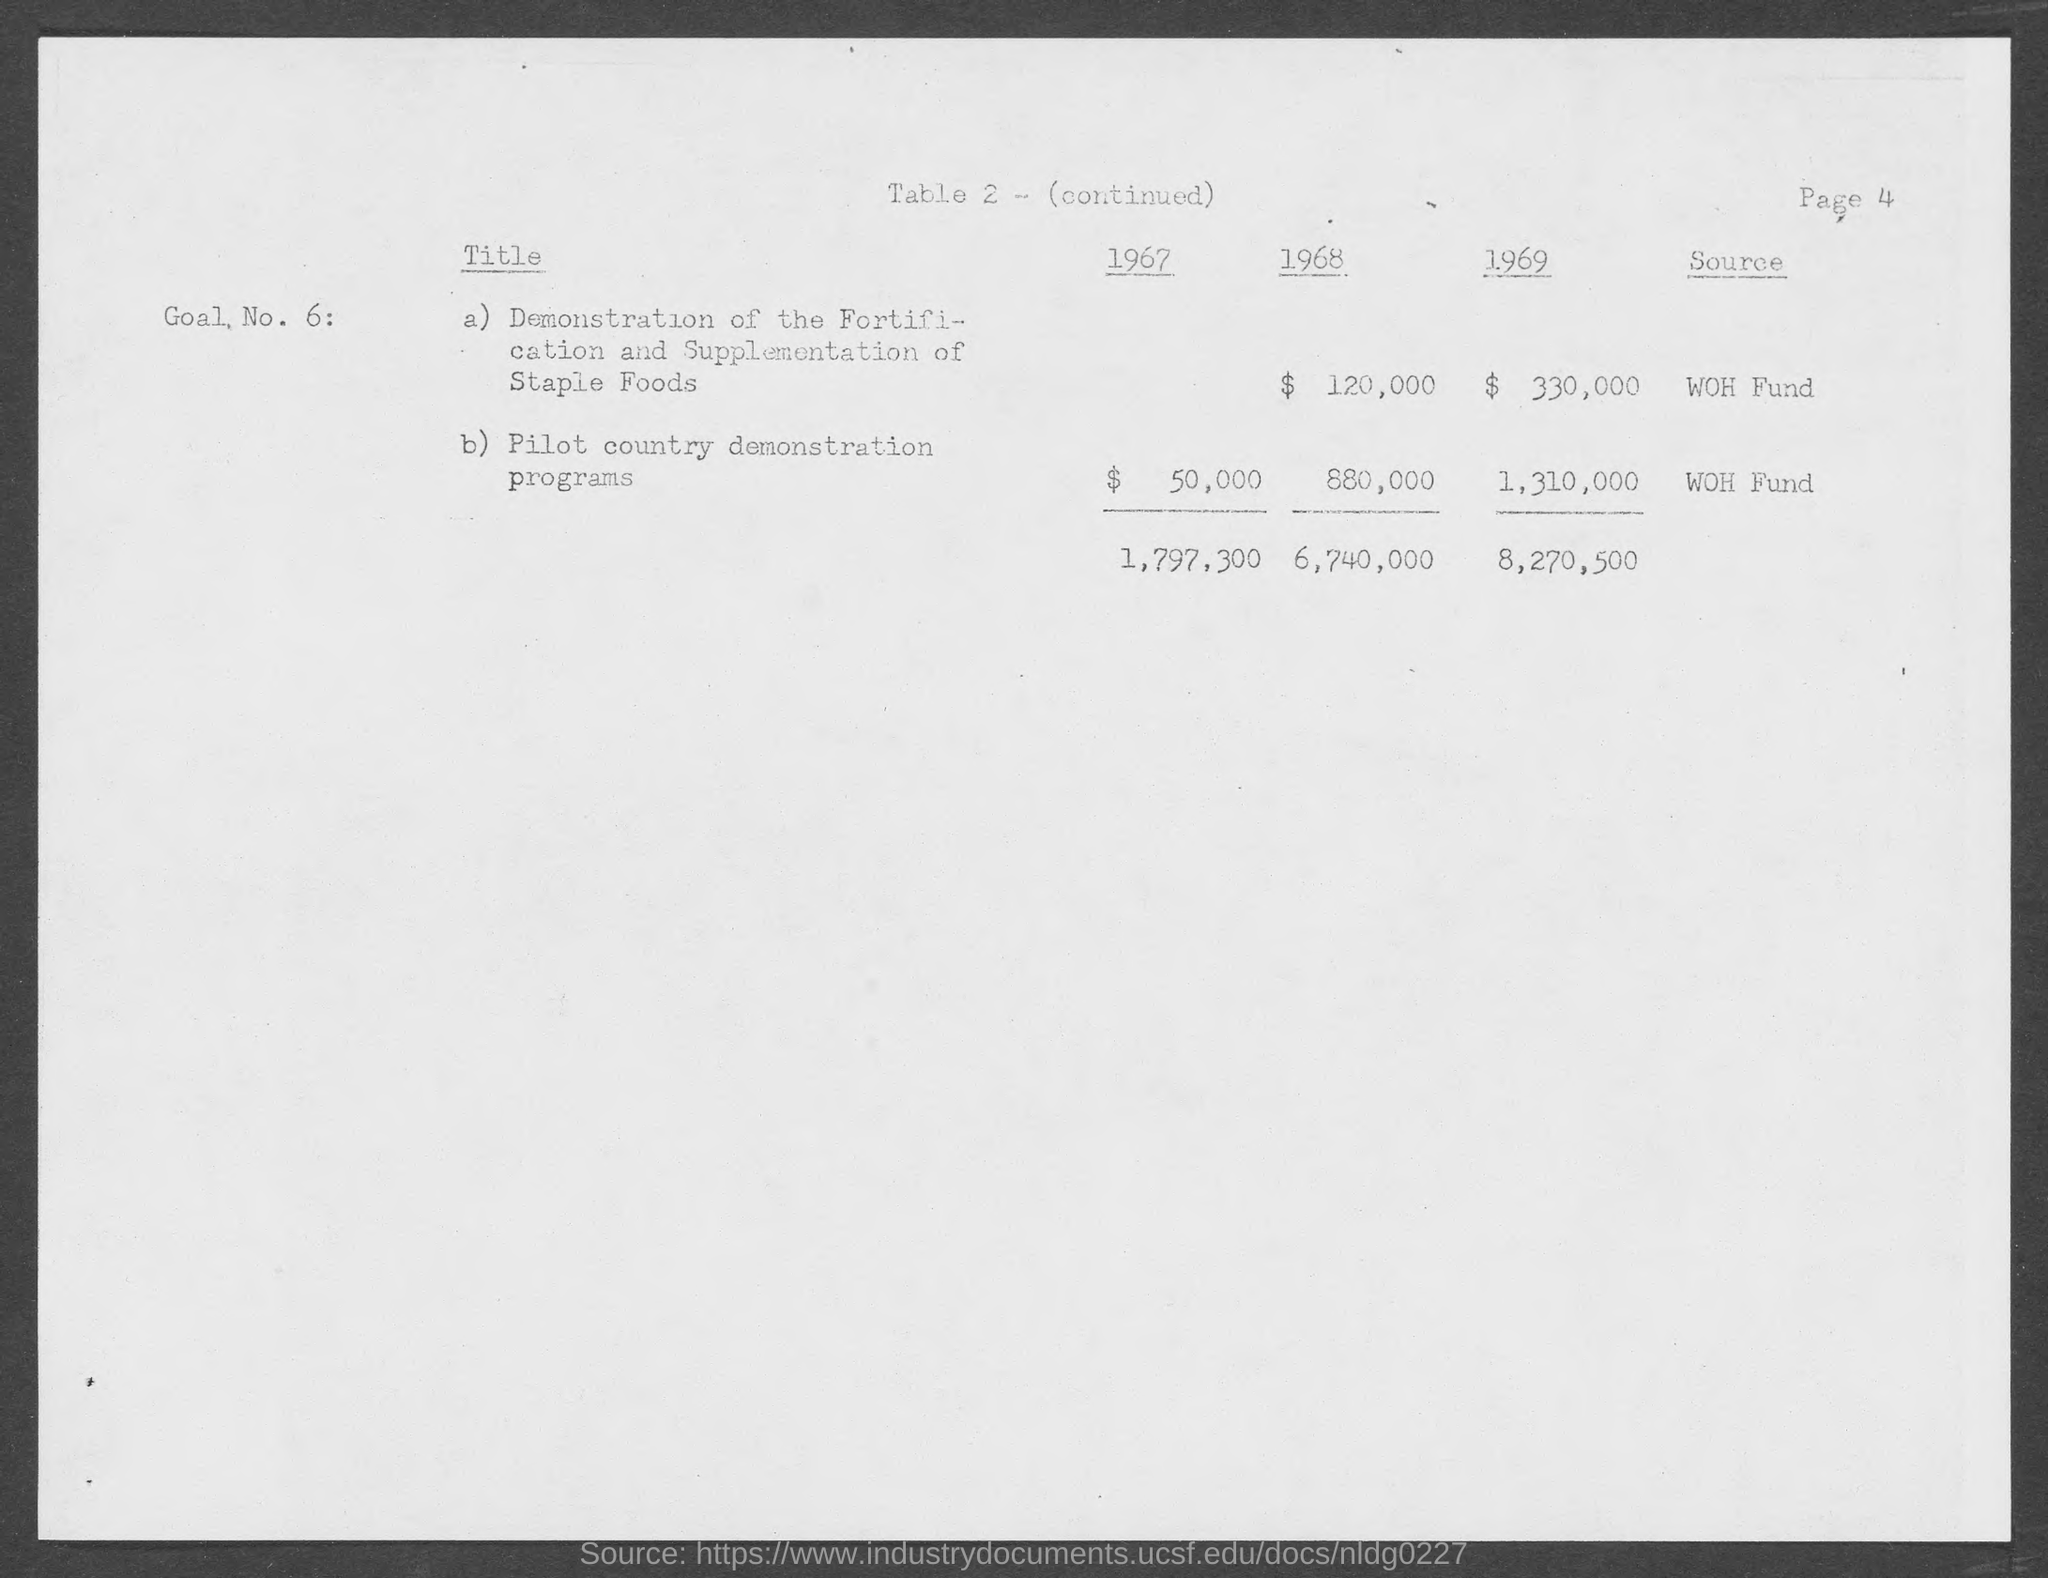Highlight a few significant elements in this photo. In the year 1967, the cost of Pilot country demonstration programs was $50,000. The funding for the demonstration of fortification and supplementation of staple foods comes from the WOH Fund. The source of funding for pilot country demonstration programs is the WOH FUND. The page number mentioned in this document is 4. The cost for the demonstration of fortification and supplementation of staple foods in the year 1968 was $120,000. 